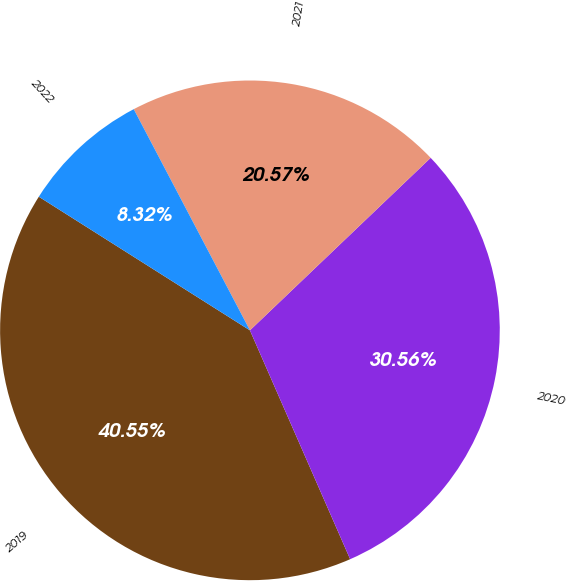<chart> <loc_0><loc_0><loc_500><loc_500><pie_chart><fcel>2019<fcel>2020<fcel>2021<fcel>2022<nl><fcel>40.55%<fcel>30.56%<fcel>20.57%<fcel>8.32%<nl></chart> 